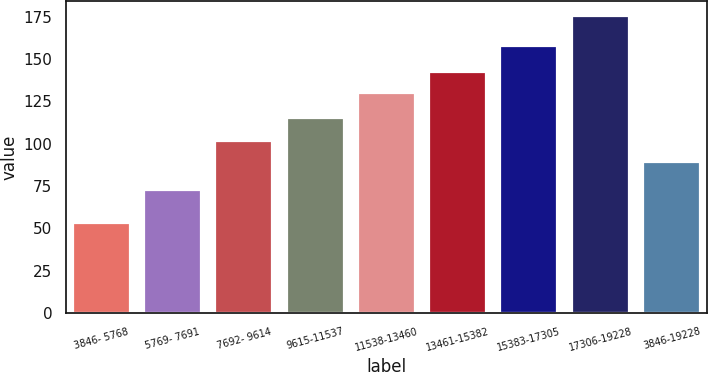Convert chart. <chart><loc_0><loc_0><loc_500><loc_500><bar_chart><fcel>3846- 5768<fcel>5769- 7691<fcel>7692- 9614<fcel>9615-11537<fcel>11538-13460<fcel>13461-15382<fcel>15383-17305<fcel>17306-19228<fcel>3846-19228<nl><fcel>53.28<fcel>72.55<fcel>101.59<fcel>114.99<fcel>129.96<fcel>142.18<fcel>157.81<fcel>175.47<fcel>89.37<nl></chart> 